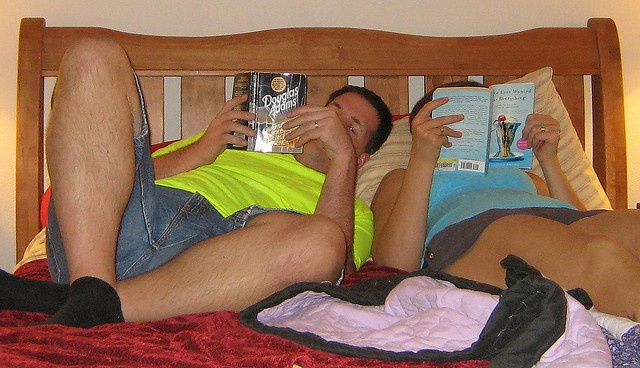Describe the objects in this image and their specific colors. I can see bed in tan, brown, maroon, and black tones, people in tan, gray, black, and brown tones, people in tan, brown, gray, teal, and maroon tones, book in tan, darkgray, teal, and gray tones, and book in tan, black, gray, white, and darkgray tones in this image. 